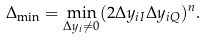<formula> <loc_0><loc_0><loc_500><loc_500>\Delta _ { \min } = \min _ { \Delta y _ { i } \neq 0 } ( 2 \Delta y _ { i I } \Delta y _ { i Q } ) ^ { n } .</formula> 